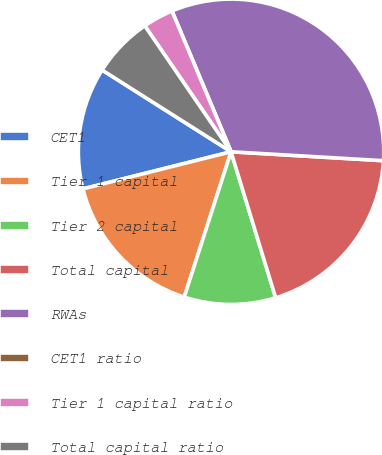Convert chart. <chart><loc_0><loc_0><loc_500><loc_500><pie_chart><fcel>CET1<fcel>Tier 1 capital<fcel>Tier 2 capital<fcel>Total capital<fcel>RWAs<fcel>CET1 ratio<fcel>Tier 1 capital ratio<fcel>Total capital ratio<nl><fcel>12.9%<fcel>16.13%<fcel>9.68%<fcel>19.35%<fcel>32.26%<fcel>0.0%<fcel>3.23%<fcel>6.45%<nl></chart> 